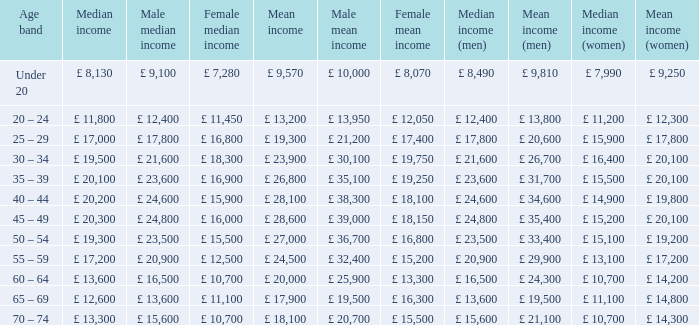Name the median income for age band being under 20 £ 8,130. 